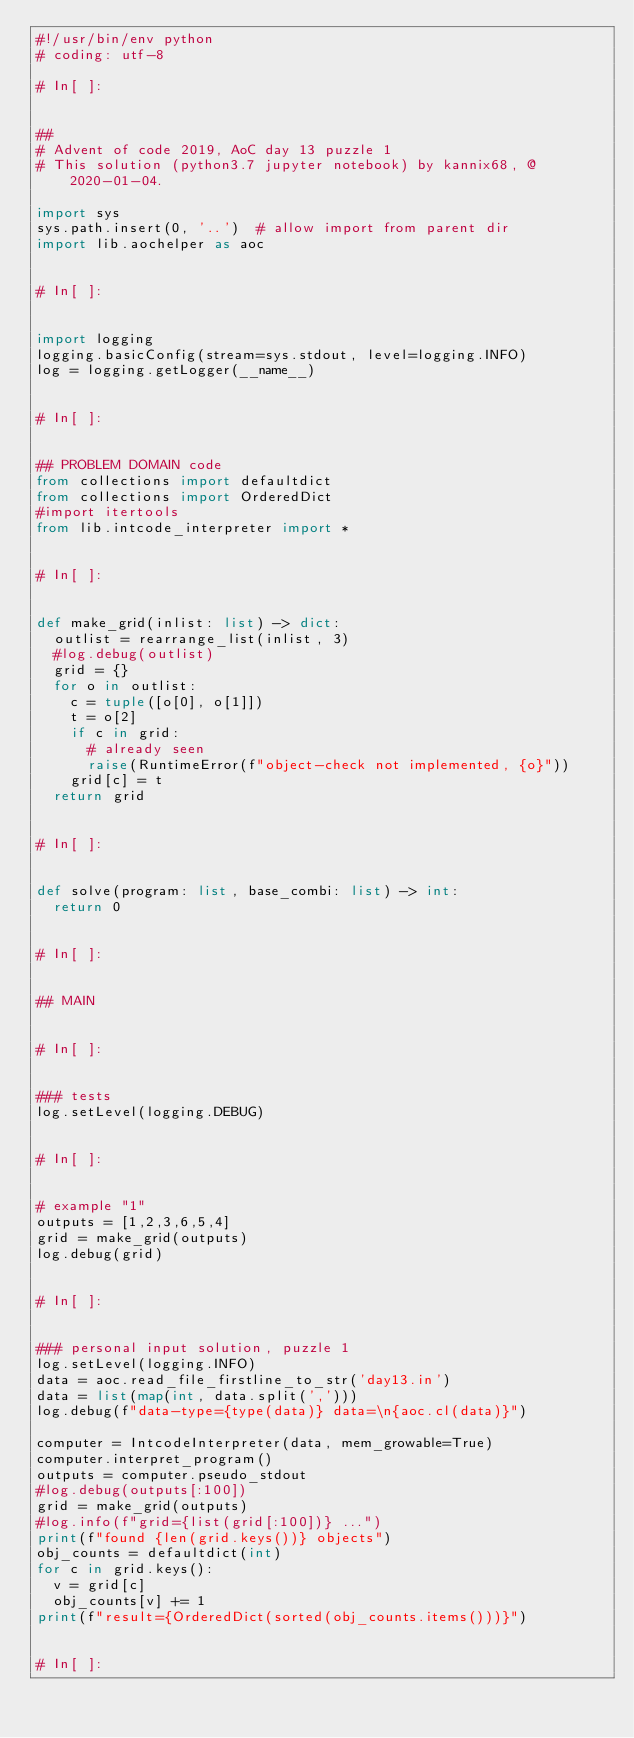Convert code to text. <code><loc_0><loc_0><loc_500><loc_500><_Python_>#!/usr/bin/env python
# coding: utf-8

# In[ ]:


##
# Advent of code 2019, AoC day 13 puzzle 1
# This solution (python3.7 jupyter notebook) by kannix68, @ 2020-01-04.

import sys
sys.path.insert(0, '..')  # allow import from parent dir
import lib.aochelper as aoc


# In[ ]:


import logging
logging.basicConfig(stream=sys.stdout, level=logging.INFO)
log = logging.getLogger(__name__)


# In[ ]:


## PROBLEM DOMAIN code
from collections import defaultdict
from collections import OrderedDict
#import itertools
from lib.intcode_interpreter import *


# In[ ]:


def make_grid(inlist: list) -> dict:
  outlist = rearrange_list(inlist, 3)
  #log.debug(outlist)    
  grid = {}
  for o in outlist:
    c = tuple([o[0], o[1]])
    t = o[2]
    if c in grid:
      # already seen
      raise(RuntimeError(f"object-check not implemented, {o}"))
    grid[c] = t
  return grid


# In[ ]:


def solve(program: list, base_combi: list) -> int:
  return 0


# In[ ]:


## MAIN


# In[ ]:


### tests
log.setLevel(logging.DEBUG)


# In[ ]:


# example "1"
outputs = [1,2,3,6,5,4]
grid = make_grid(outputs)
log.debug(grid)


# In[ ]:


### personal input solution, puzzle 1
log.setLevel(logging.INFO)
data = aoc.read_file_firstline_to_str('day13.in')
data = list(map(int, data.split(',')))
log.debug(f"data-type={type(data)} data=\n{aoc.cl(data)}")

computer = IntcodeInterpreter(data, mem_growable=True)
computer.interpret_program()
outputs = computer.pseudo_stdout
#log.debug(outputs[:100])
grid = make_grid(outputs)
#log.info(f"grid={list(grid[:100])} ...")
print(f"found {len(grid.keys())} objects")
obj_counts = defaultdict(int)
for c in grid.keys():
  v = grid[c]
  obj_counts[v] += 1
print(f"result={OrderedDict(sorted(obj_counts.items()))}")


# In[ ]:




</code> 